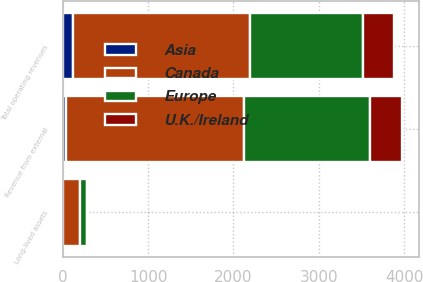Convert chart. <chart><loc_0><loc_0><loc_500><loc_500><stacked_bar_chart><ecel><fcel>Revenue from external<fcel>Total operating revenues<fcel>Long-lived assets<nl><fcel>Canada<fcel>2090.2<fcel>2082.1<fcel>196.7<nl><fcel>Europe<fcel>1473.1<fcel>1320.3<fcel>81.5<nl><fcel>U.K./Ireland<fcel>372.3<fcel>358.2<fcel>7.9<nl><fcel>Asia<fcel>38.8<fcel>115.5<fcel>4.9<nl></chart> 